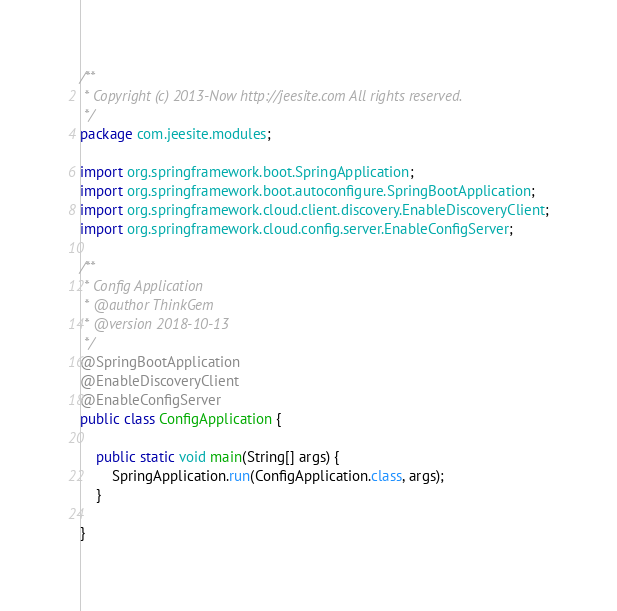Convert code to text. <code><loc_0><loc_0><loc_500><loc_500><_Java_>/**
 * Copyright (c) 2013-Now http://jeesite.com All rights reserved.
 */
package com.jeesite.modules;

import org.springframework.boot.SpringApplication;
import org.springframework.boot.autoconfigure.SpringBootApplication;
import org.springframework.cloud.client.discovery.EnableDiscoveryClient;
import org.springframework.cloud.config.server.EnableConfigServer;

/**
 * Config Application
 * @author ThinkGem
 * @version 2018-10-13
 */
@SpringBootApplication
@EnableDiscoveryClient
@EnableConfigServer
public class ConfigApplication {
	
	public static void main(String[] args) {
		SpringApplication.run(ConfigApplication.class, args);
	}
	
}</code> 